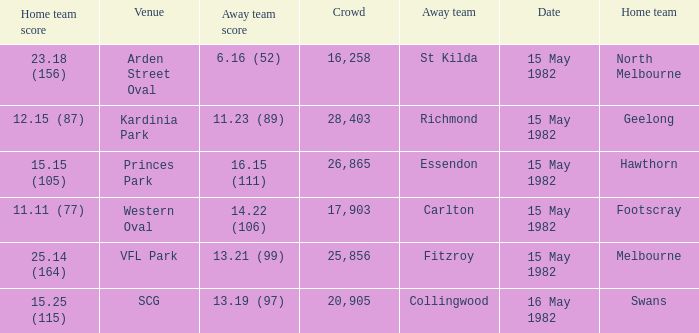Where did Geelong play as the home team? Kardinia Park. 